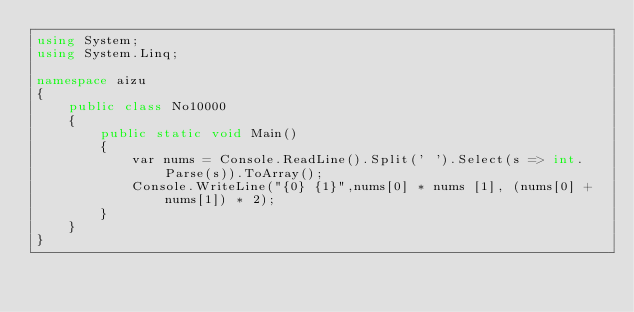<code> <loc_0><loc_0><loc_500><loc_500><_C#_>using System;
using System.Linq;

namespace aizu
{
    public class No10000
    {
        public static void Main()
        {
            var nums = Console.ReadLine().Split(' ').Select(s => int.Parse(s)).ToArray();
            Console.WriteLine("{0} {1}",nums[0] * nums [1], (nums[0] + nums[1]) * 2);
        }
    }
}</code> 